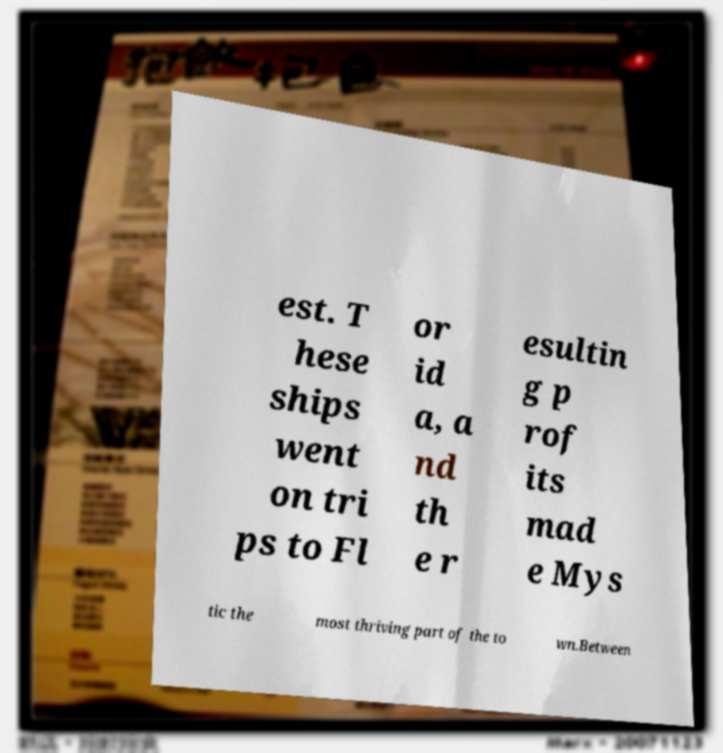Could you extract and type out the text from this image? est. T hese ships went on tri ps to Fl or id a, a nd th e r esultin g p rof its mad e Mys tic the most thriving part of the to wn.Between 